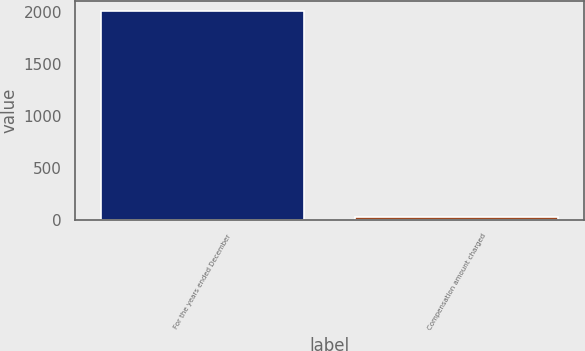<chart> <loc_0><loc_0><loc_500><loc_500><bar_chart><fcel>For the years ended December<fcel>Compensation amount charged<nl><fcel>2008<fcel>27.2<nl></chart> 